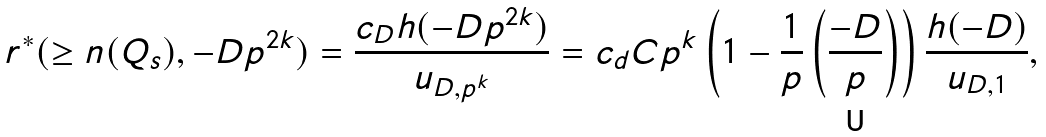<formula> <loc_0><loc_0><loc_500><loc_500>r ^ { * } ( \geq n ( Q _ { s } ) , - D p ^ { 2 k } ) = \frac { c _ { D } h ( - D p ^ { 2 k } ) } { u _ { D , p ^ { k } } } = c _ { d } C p ^ { k } \left ( 1 - \frac { 1 } { p } \left ( \frac { - D } { p } \right ) \right ) \frac { h ( - D ) } { u _ { D , 1 } } ,</formula> 